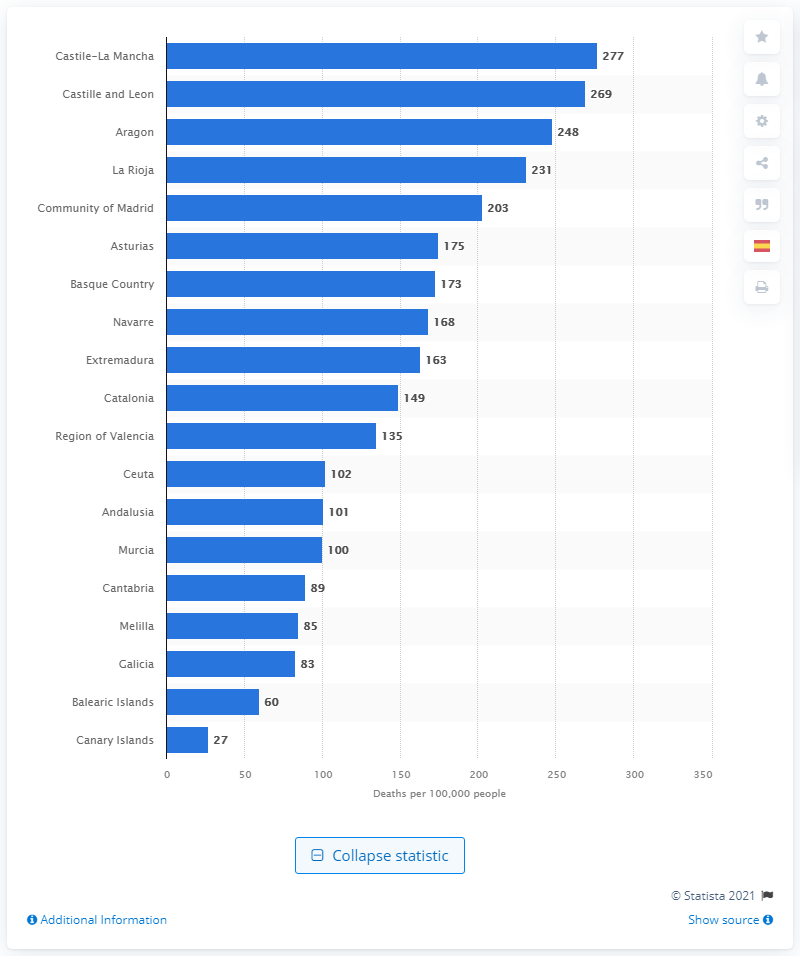Highlight a few significant elements in this photo. Catalonia, a Mediterranean autonomous community, had one of the highest number of cases of the coronavirus. 